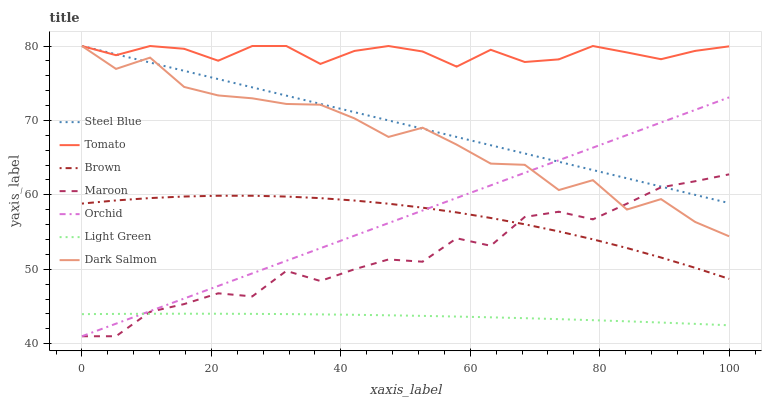Does Brown have the minimum area under the curve?
Answer yes or no. No. Does Brown have the maximum area under the curve?
Answer yes or no. No. Is Brown the smoothest?
Answer yes or no. No. Is Brown the roughest?
Answer yes or no. No. Does Brown have the lowest value?
Answer yes or no. No. Does Brown have the highest value?
Answer yes or no. No. Is Light Green less than Tomato?
Answer yes or no. Yes. Is Dark Salmon greater than Brown?
Answer yes or no. Yes. Does Light Green intersect Tomato?
Answer yes or no. No. 